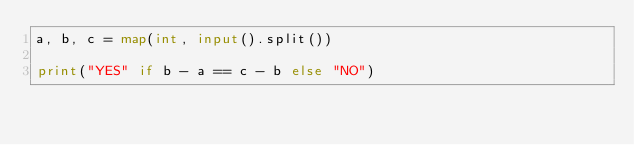Convert code to text. <code><loc_0><loc_0><loc_500><loc_500><_Python_>a, b, c = map(int, input().split())

print("YES" if b - a == c - b else "NO")</code> 